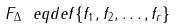Convert formula to latex. <formula><loc_0><loc_0><loc_500><loc_500>F _ { \Delta } \ e q d e f \{ f _ { 1 } , f _ { 2 } , \dots , f _ { r } \}</formula> 